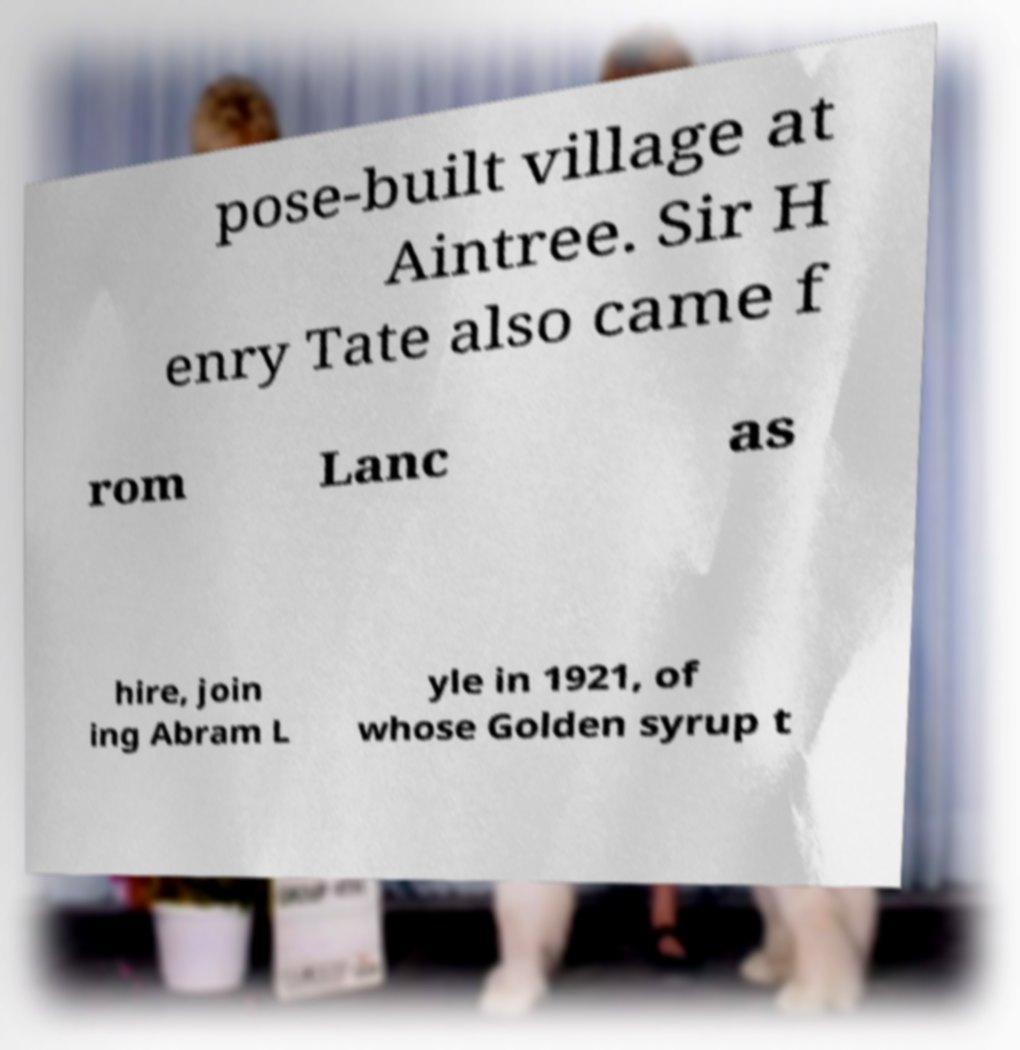I need the written content from this picture converted into text. Can you do that? pose-built village at Aintree. Sir H enry Tate also came f rom Lanc as hire, join ing Abram L yle in 1921, of whose Golden syrup t 